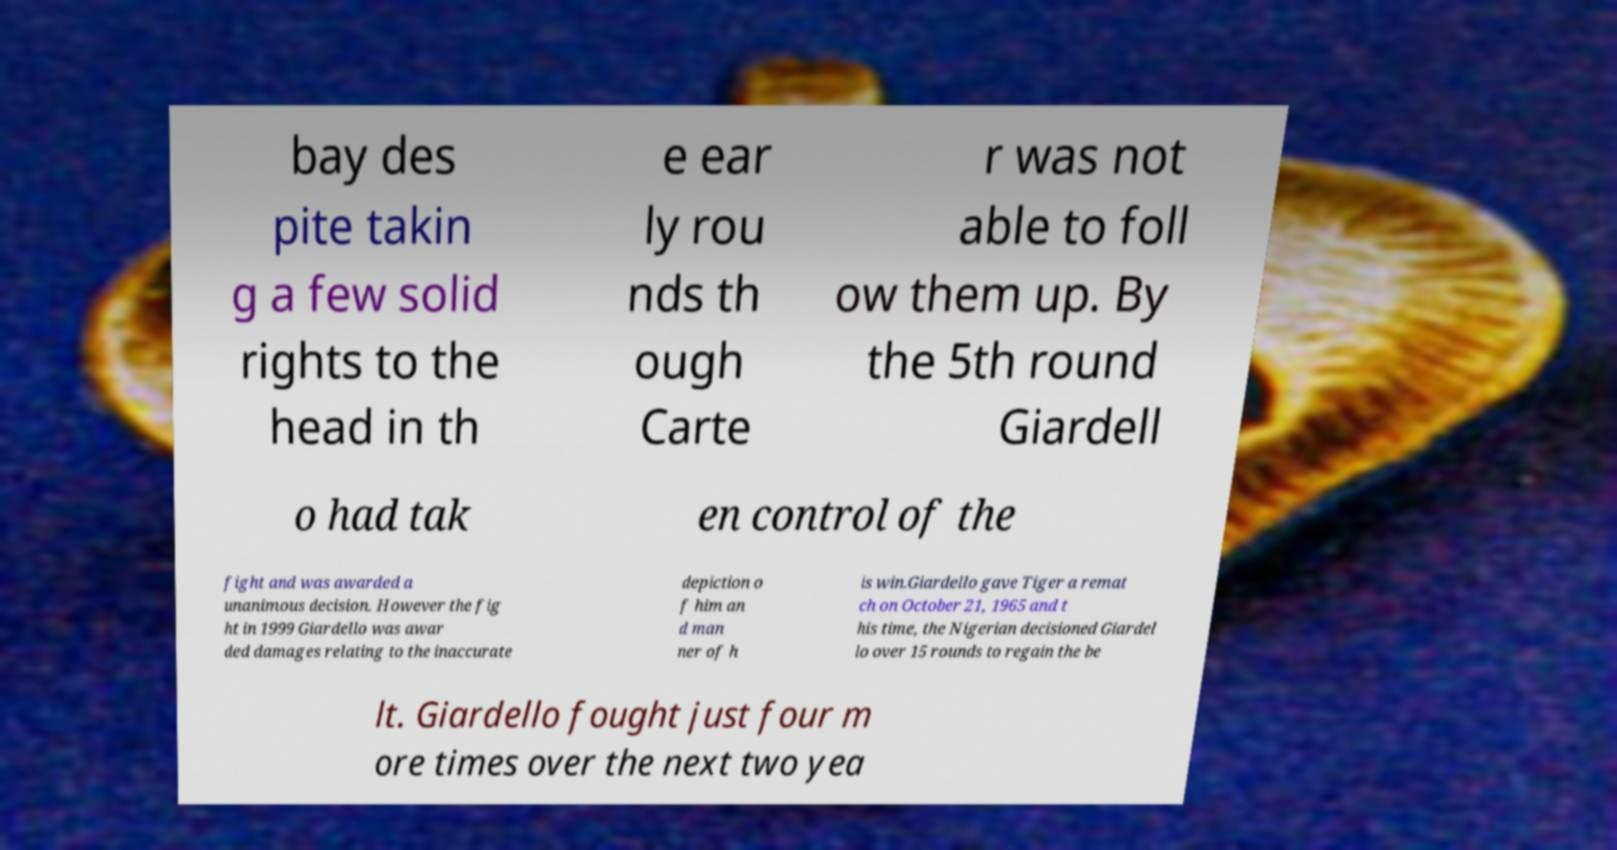I need the written content from this picture converted into text. Can you do that? bay des pite takin g a few solid rights to the head in th e ear ly rou nds th ough Carte r was not able to foll ow them up. By the 5th round Giardell o had tak en control of the fight and was awarded a unanimous decision. However the fig ht in 1999 Giardello was awar ded damages relating to the inaccurate depiction o f him an d man ner of h is win.Giardello gave Tiger a remat ch on October 21, 1965 and t his time, the Nigerian decisioned Giardel lo over 15 rounds to regain the be lt. Giardello fought just four m ore times over the next two yea 